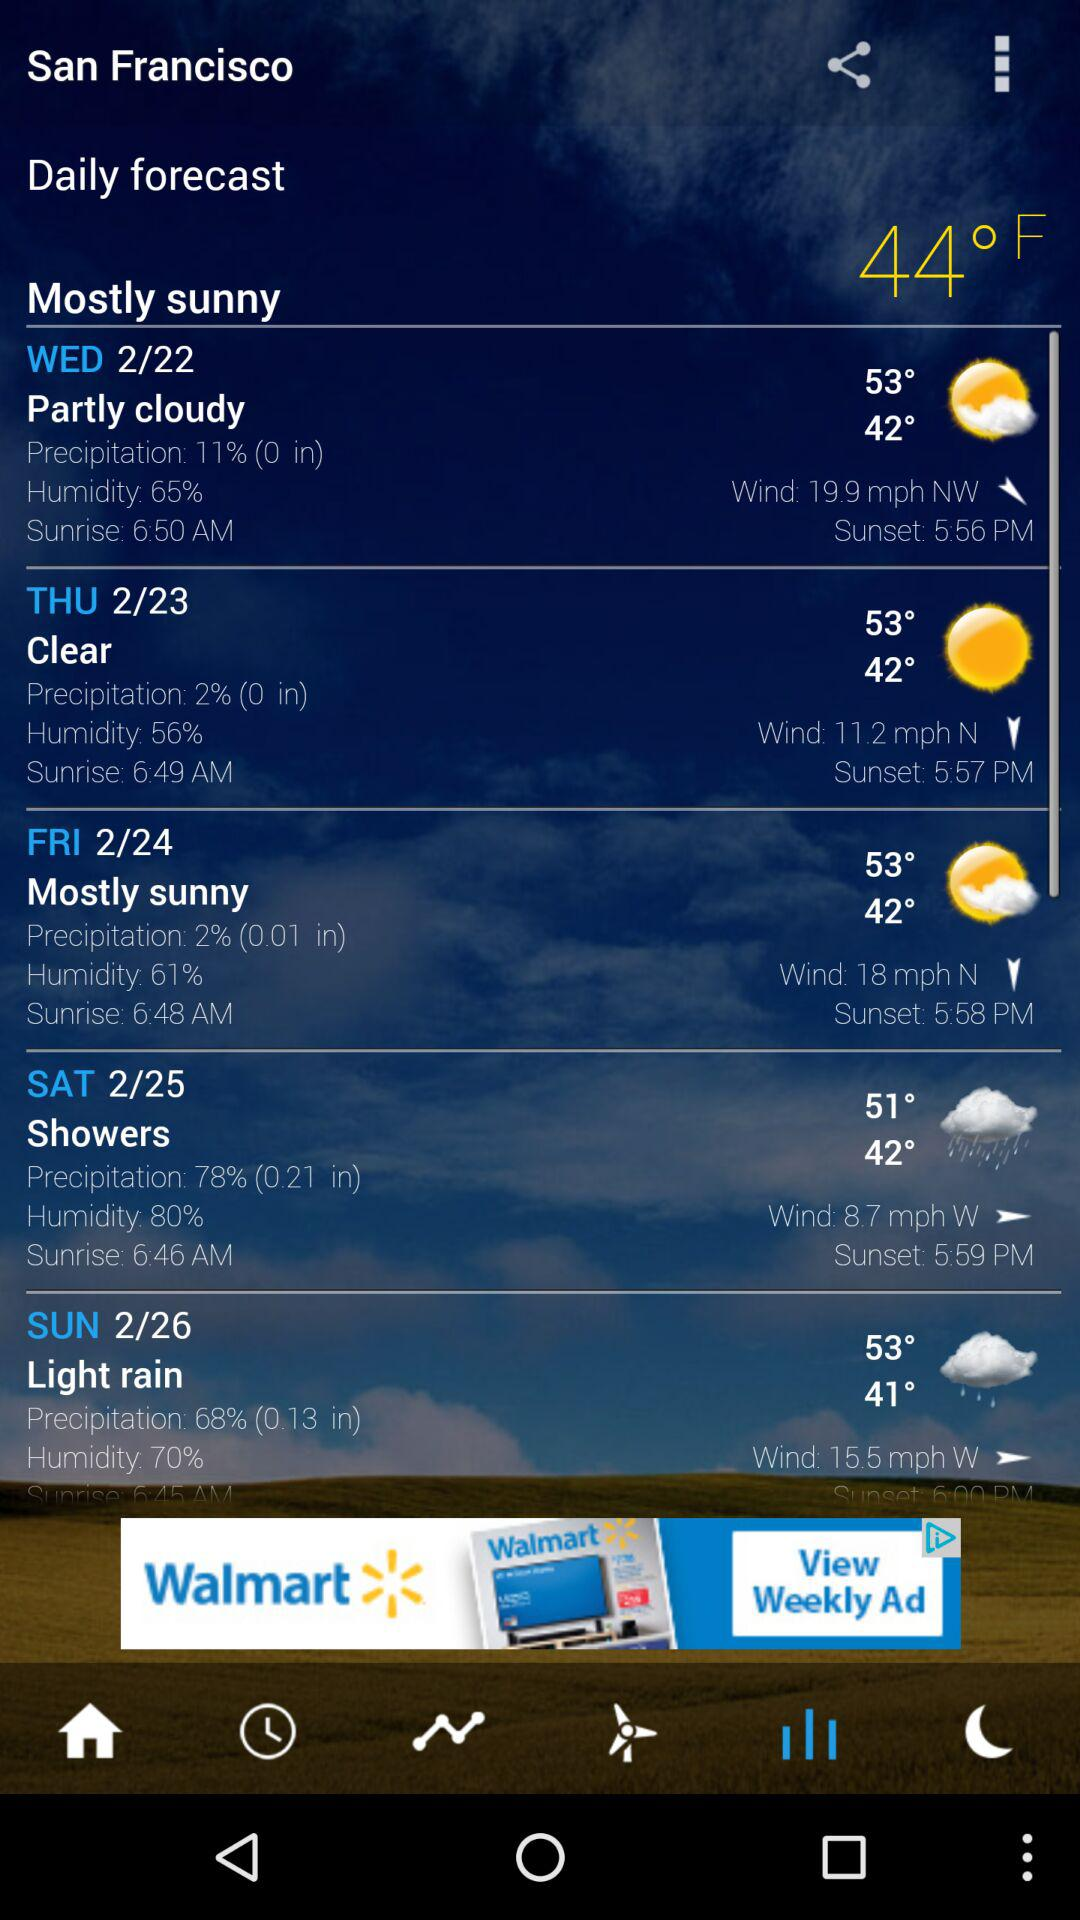What is the sunrise time on Wednesday in San Francisco? The sunrise time on Wednesday is 6:50 AM. 